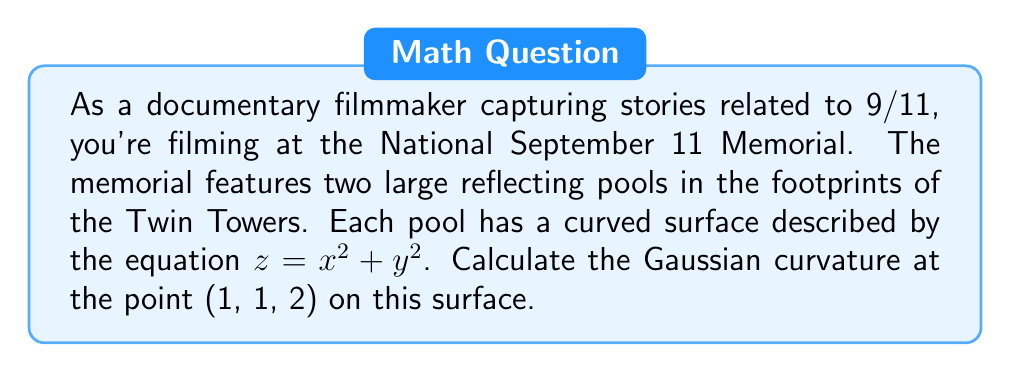Give your solution to this math problem. To calculate the Gaussian curvature of the surface $z = x^2 + y^2$ at the point (1, 1, 2), we'll follow these steps:

1) The Gaussian curvature K is given by $K = \frac{LN - M^2}{EG - F^2}$, where L, M, N are coefficients of the second fundamental form, and E, F, G are coefficients of the first fundamental form.

2) First, let's calculate the partial derivatives:
   $z_x = 2x$, $z_y = 2y$, $z_{xx} = 2$, $z_{xy} = 0$, $z_{yy} = 2$

3) Now, we can calculate E, F, G:
   $E = 1 + z_x^2 = 1 + 4x^2$
   $F = z_x z_y = 4xy$
   $G = 1 + z_y^2 = 1 + 4y^2$

4) Next, we calculate the unit normal vector:
   $\vec{n} = \frac{(-z_x, -z_y, 1)}{\sqrt{1 + z_x^2 + z_y^2}} = \frac{(-2x, -2y, 1)}{\sqrt{1 + 4x^2 + 4y^2}}$

5) Now we can calculate L, M, N:
   $L = \frac{z_{xx}}{\sqrt{1 + z_x^2 + z_y^2}} = \frac{2}{\sqrt{1 + 4x^2 + 4y^2}}$
   $M = \frac{z_{xy}}{\sqrt{1 + z_x^2 + z_y^2}} = 0$
   $N = \frac{z_{yy}}{\sqrt{1 + z_x^2 + z_y^2}} = \frac{2}{\sqrt{1 + 4x^2 + 4y^2}}$

6) At the point (1, 1, 2):
   $E = 5$, $F = 4$, $G = 5$
   $L = N = \frac{2}{3}$, $M = 0$

7) Now we can calculate the Gaussian curvature:
   $K = \frac{LN - M^2}{EG - F^2} = \frac{(\frac{2}{3})(\frac{2}{3}) - 0^2}{(5)(5) - 4^2} = \frac{4/9}{9} = \frac{4}{81}$
Answer: $\frac{4}{81}$ 